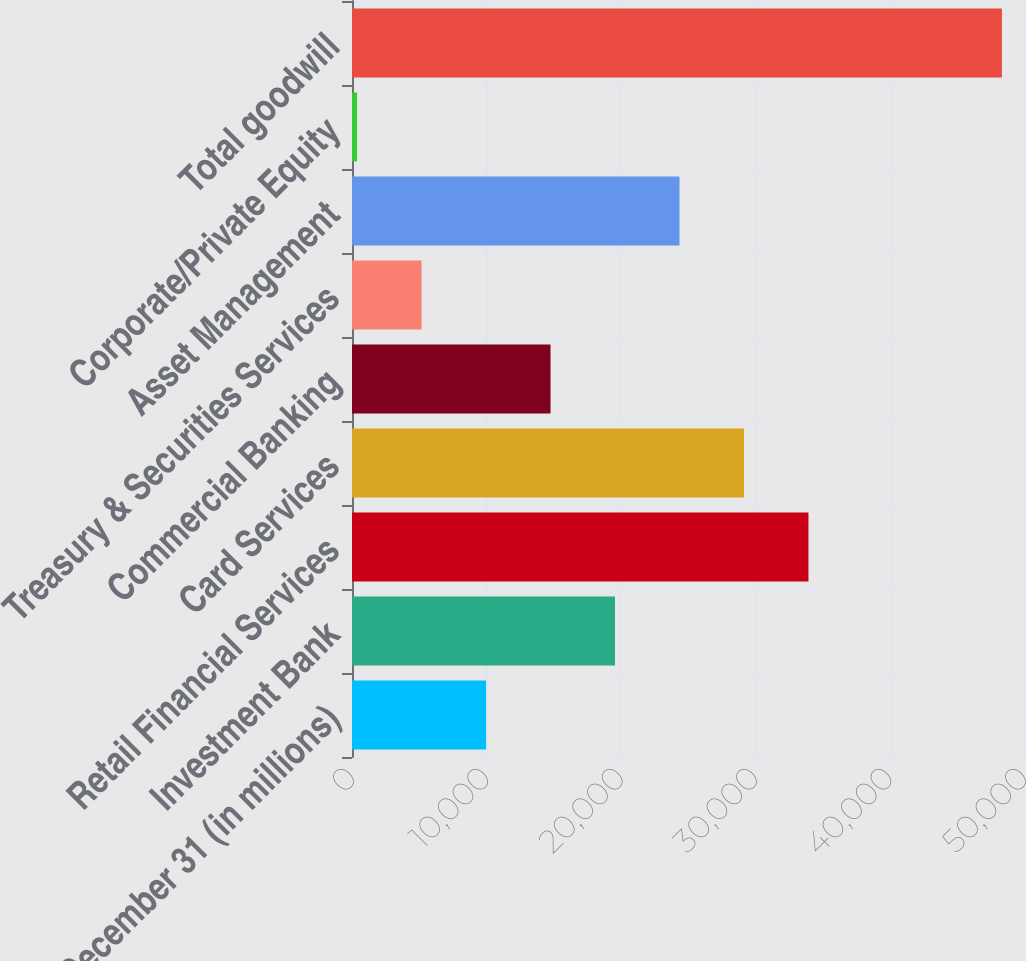Convert chart to OTSL. <chart><loc_0><loc_0><loc_500><loc_500><bar_chart><fcel>December 31 (in millions)<fcel>Investment Bank<fcel>Retail Financial Services<fcel>Card Services<fcel>Commercial Banking<fcel>Treasury & Securities Services<fcel>Asset Management<fcel>Corporate/Private Equity<fcel>Total goodwill<nl><fcel>9973<fcel>19569<fcel>33963<fcel>29165<fcel>14771<fcel>5175<fcel>24367<fcel>377<fcel>48357<nl></chart> 